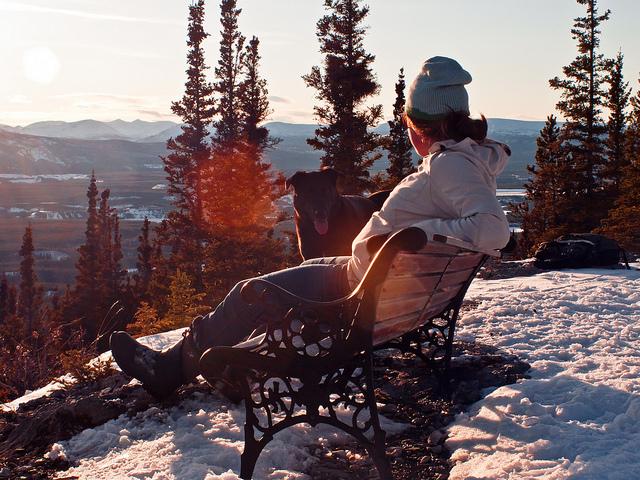Is it cold?
Answer briefly. Yes. Is it a sunny day?
Quick response, please. Yes. Does this person have a nice view?
Be succinct. Yes. 